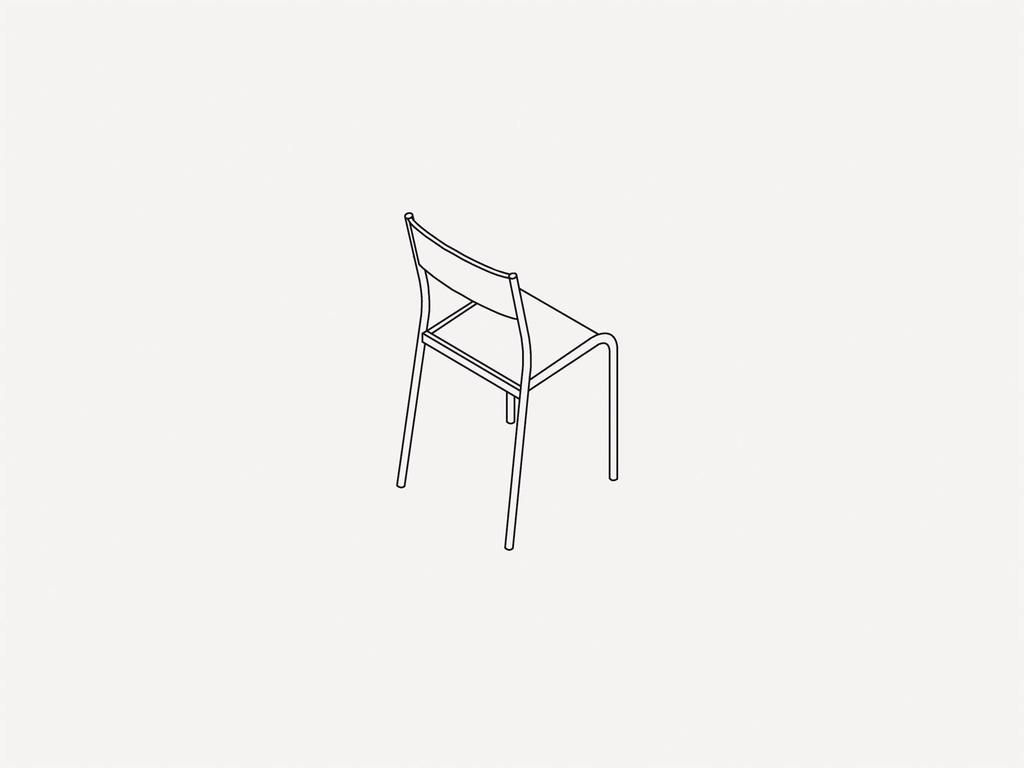What is the main subject of the sketch in the image? The main subject of the sketch in the image is a chair. What is the color of the sketch? The sketch is in black color. What is the background of the sketch? The sketch is on a white background. How many watches are visible in the image? There are no watches present in the image; it features a sketch of a chair on a white background. What type of quiver is shown in the image? There is no quiver present in the image; it features a sketch of a chair on a white background. 